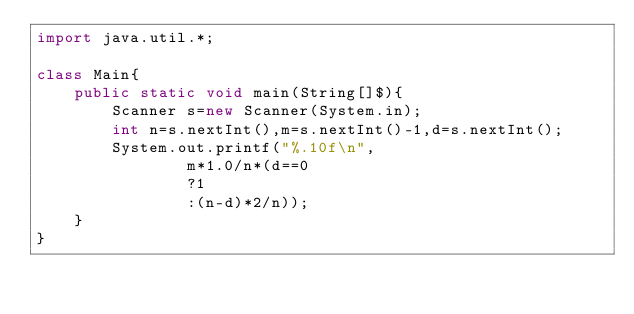Convert code to text. <code><loc_0><loc_0><loc_500><loc_500><_Java_>import java.util.*;

class Main{
	public static void main(String[]$){
		Scanner s=new Scanner(System.in);
		int n=s.nextInt(),m=s.nextInt()-1,d=s.nextInt();
		System.out.printf("%.10f\n",
				m*1.0/n*(d==0
				?1
				:(n-d)*2/n));
	}
}
</code> 